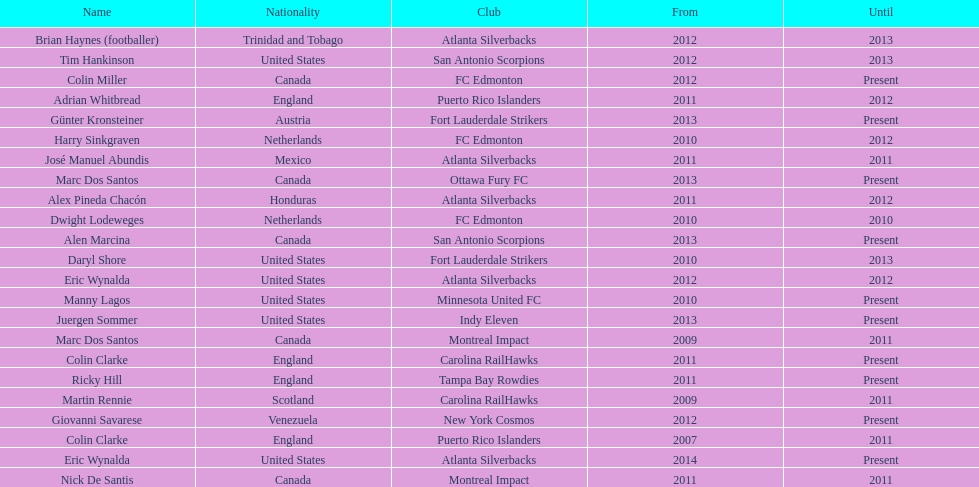What name is listed at the top? José Manuel Abundis. 